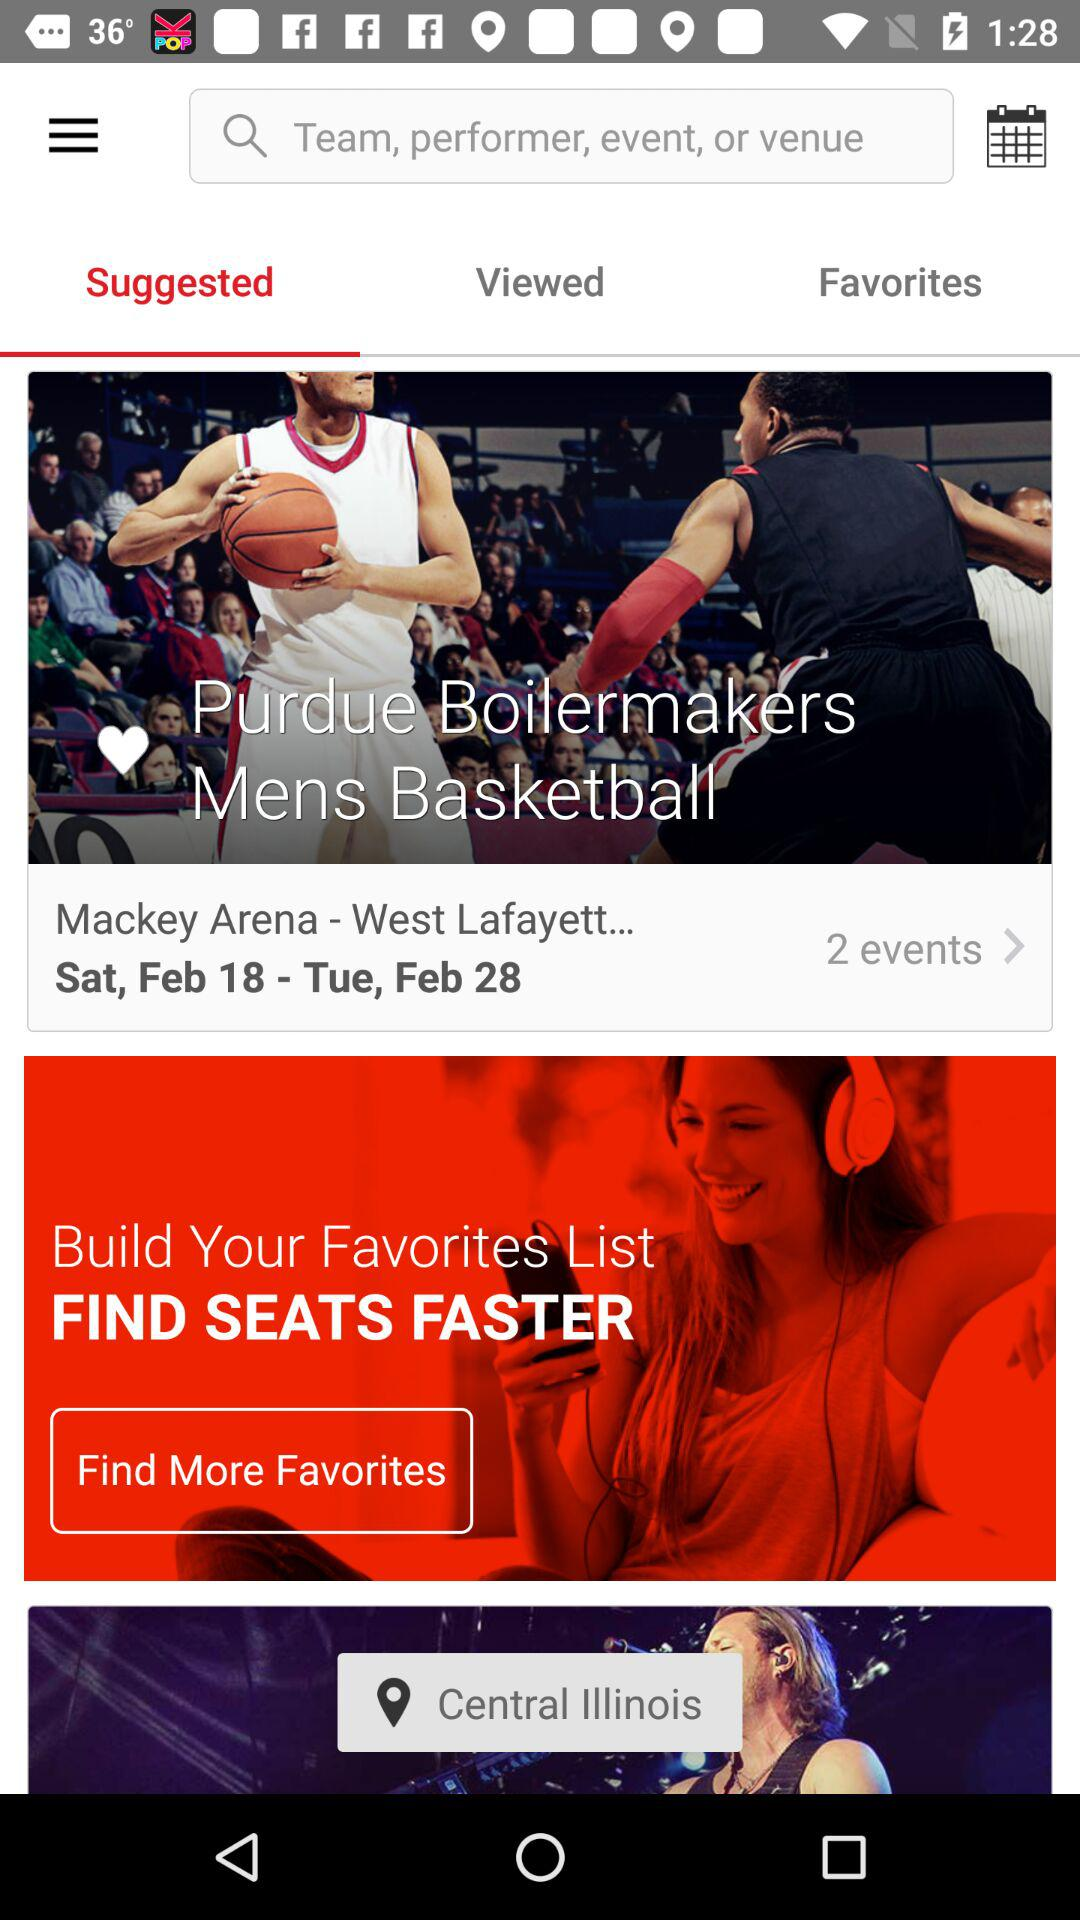Which stories are saved in "Favorites"?
When the provided information is insufficient, respond with <no answer>. <no answer> 